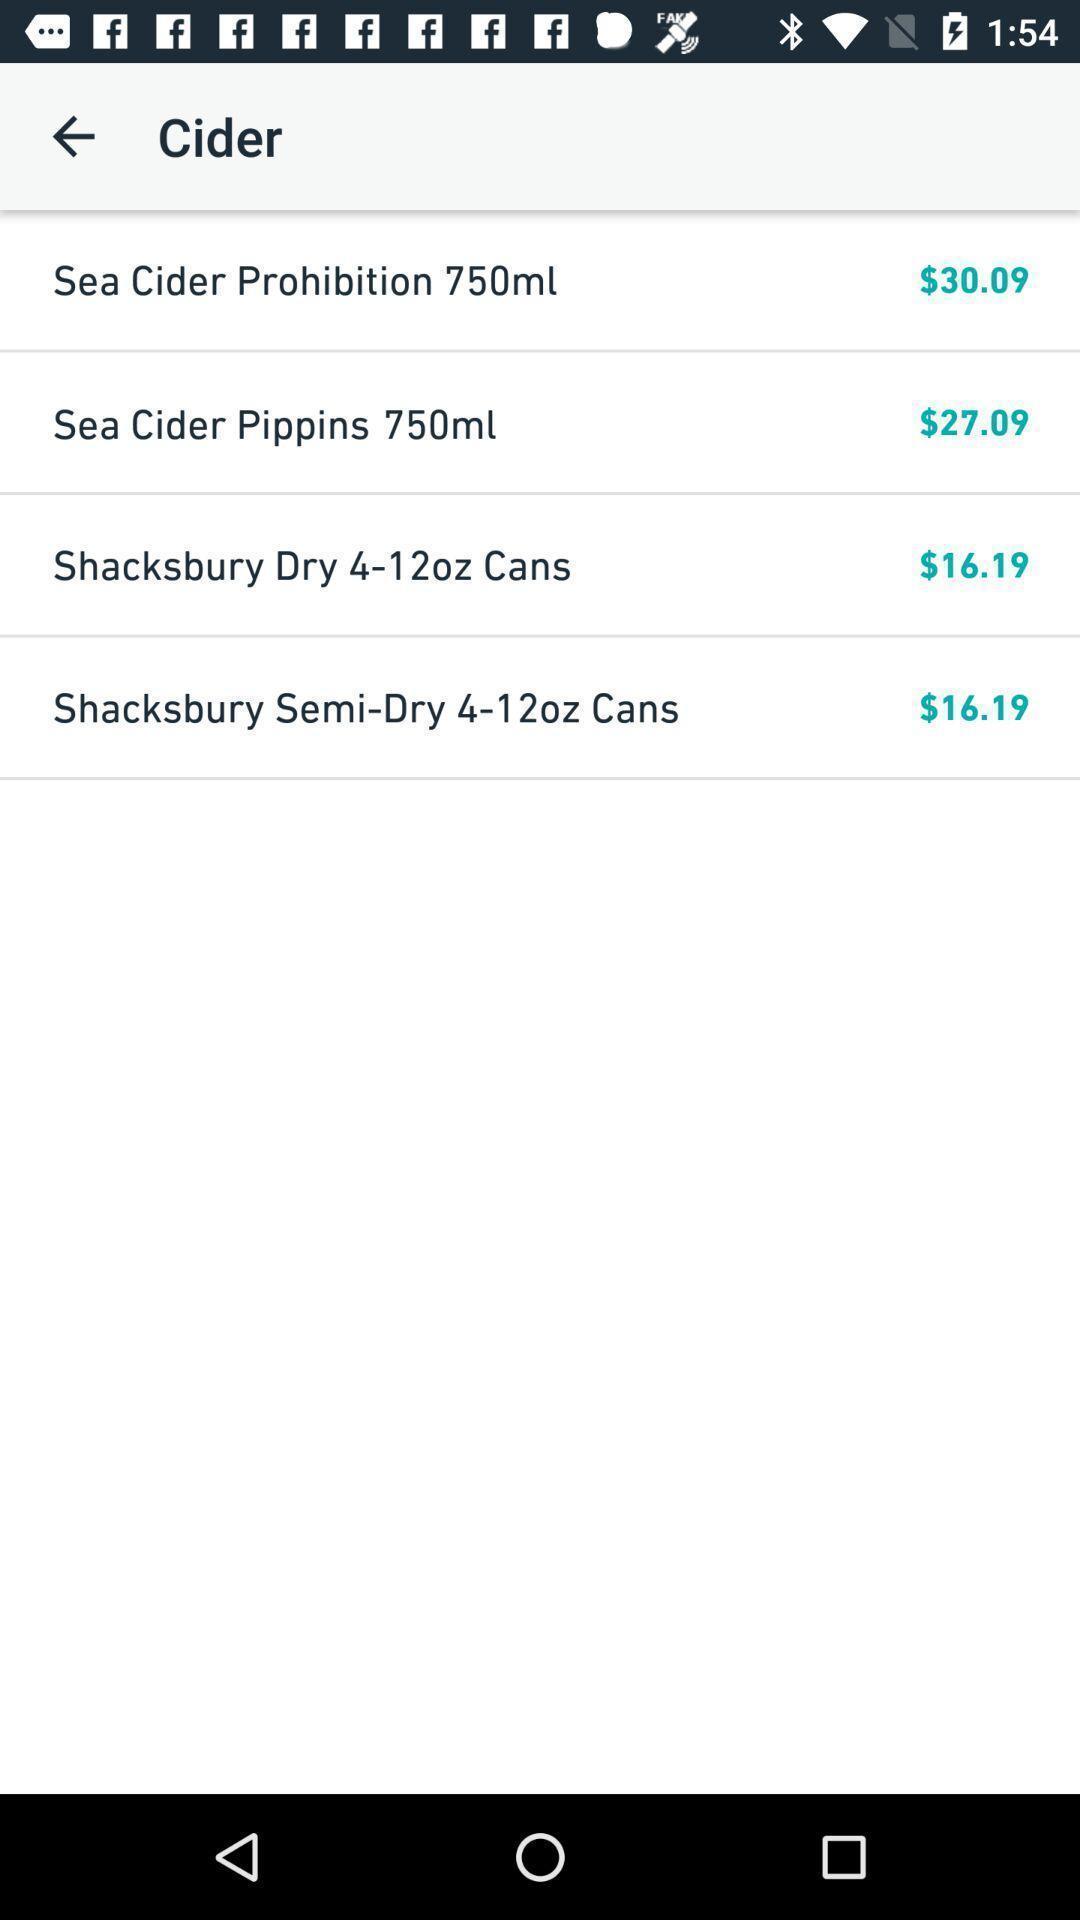What is the overall content of this screenshot? Screen displaying various cider options in food app. 